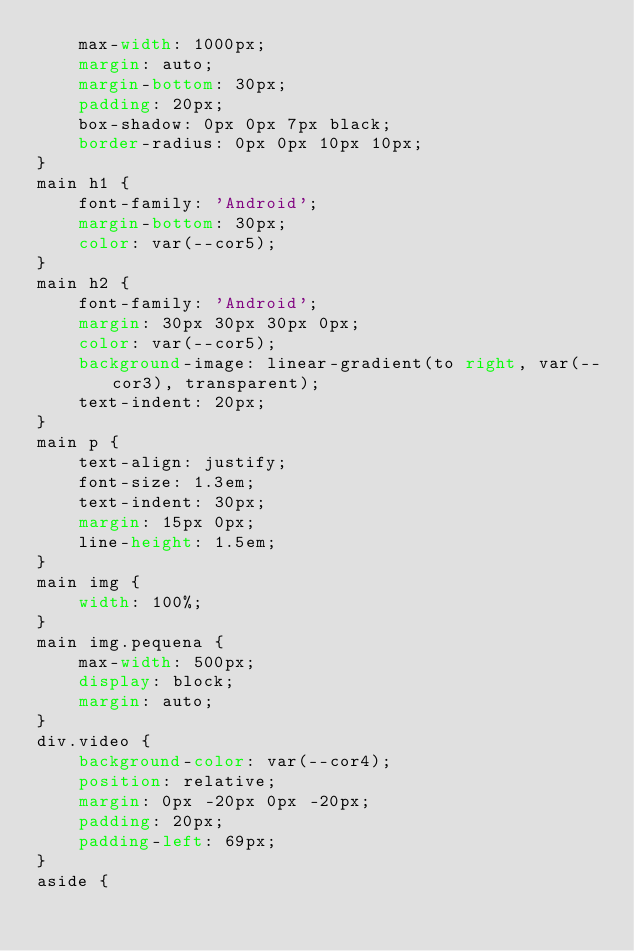Convert code to text. <code><loc_0><loc_0><loc_500><loc_500><_CSS_>    max-width: 1000px;
    margin: auto;
    margin-bottom: 30px;
    padding: 20px;
    box-shadow: 0px 0px 7px black;
    border-radius: 0px 0px 10px 10px;
}
main h1 {
    font-family: 'Android';
    margin-bottom: 30px;
    color: var(--cor5);
}
main h2 {
    font-family: 'Android';
    margin: 30px 30px 30px 0px;
    color: var(--cor5);
    background-image: linear-gradient(to right, var(--cor3), transparent);
    text-indent: 20px;
}
main p {
    text-align: justify;
    font-size: 1.3em;
    text-indent: 30px;
    margin: 15px 0px;
    line-height: 1.5em;
}
main img {
    width: 100%;
}
main img.pequena {
    max-width: 500px;
    display: block;
    margin: auto;
}
div.video {
    background-color: var(--cor4);
    position: relative;
    margin: 0px -20px 0px -20px;
    padding: 20px;
    padding-left: 69px;
}
aside {</code> 